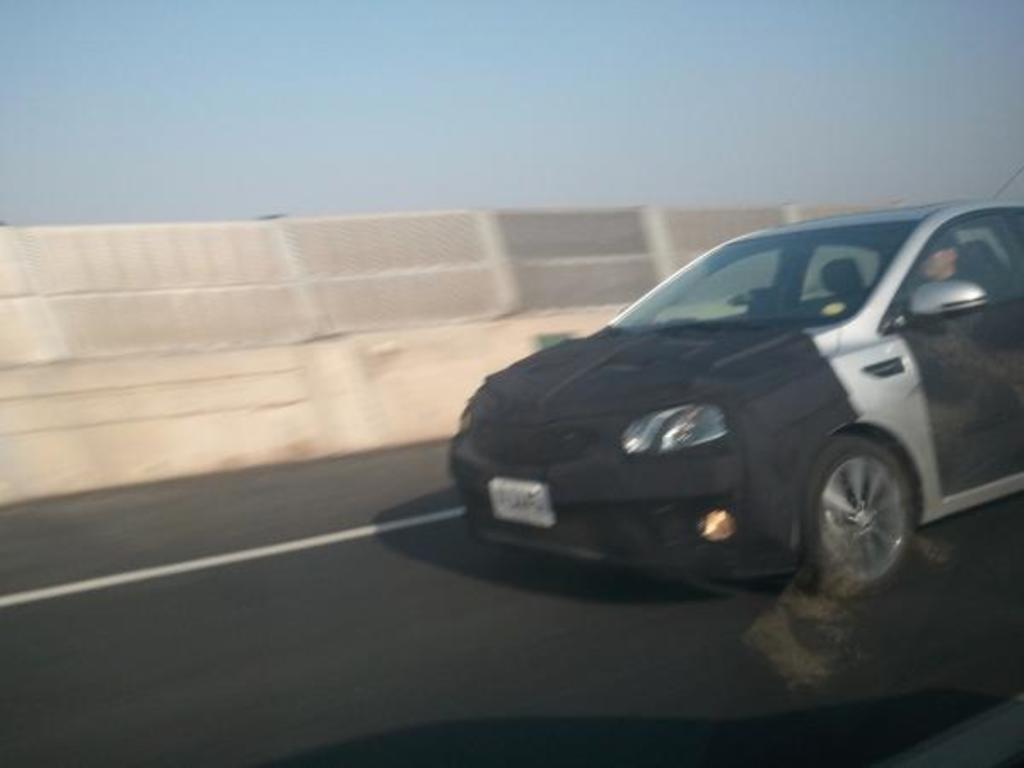What is the main subject of the image? The main subject of the image is a car. Where is the car located in the image? The car is on the road in the image. What color is the car? The car is black in color. What can be seen in the background of the image? There is a wall and the sky visible in the background of the image. How many geese are flying over the car in the image? There are no geese present in the image; it only features a car on the road. What type of rings can be seen on the car's tires in the image? There are no rings visible on the car's tires in the image. 